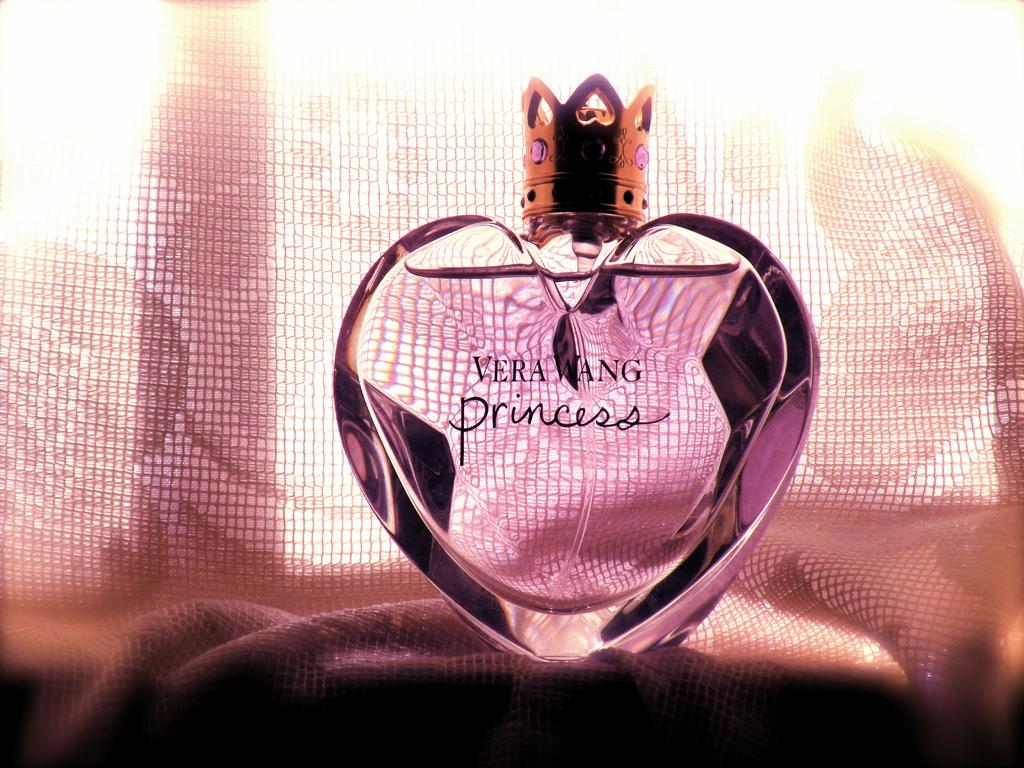<image>
Provide a brief description of the given image. The new bottle design for the Vera Wang Princess perfume 